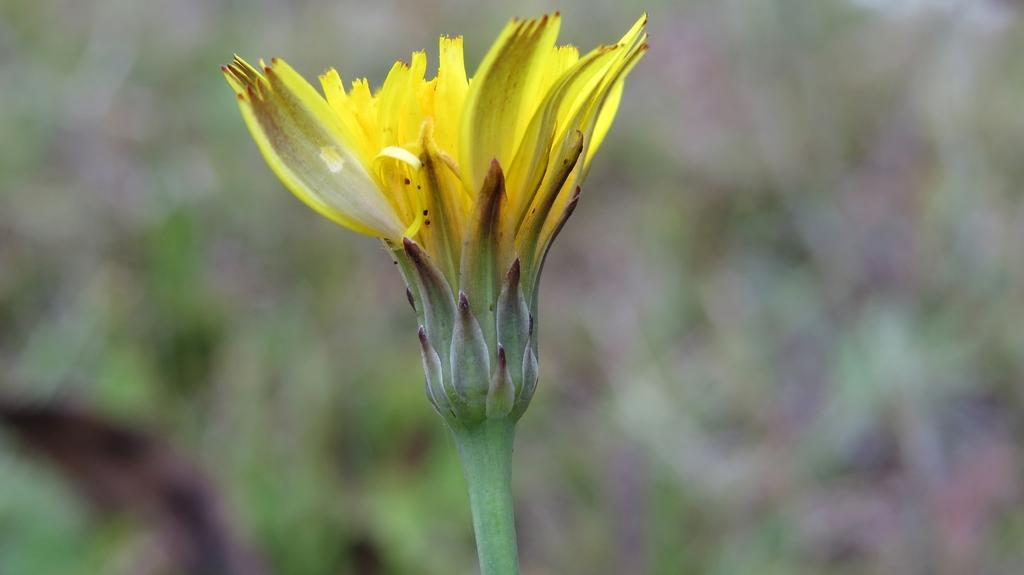What is the main subject of the image? There is a flower in the center of the image. Can you describe the flower in the image? The flower is the main focus of the image, but no specific details about its color, size, or type are provided. Are there any other objects or elements in the image besides the flower? No additional information is given about the image, so we can only assume that the flower is the sole subject. How many feet are visible in the image? There are no feet present in the image; it only features a flower. Is there an airplane flying in the background of the image? No, there is no mention of an airplane or any background elements in the image. 